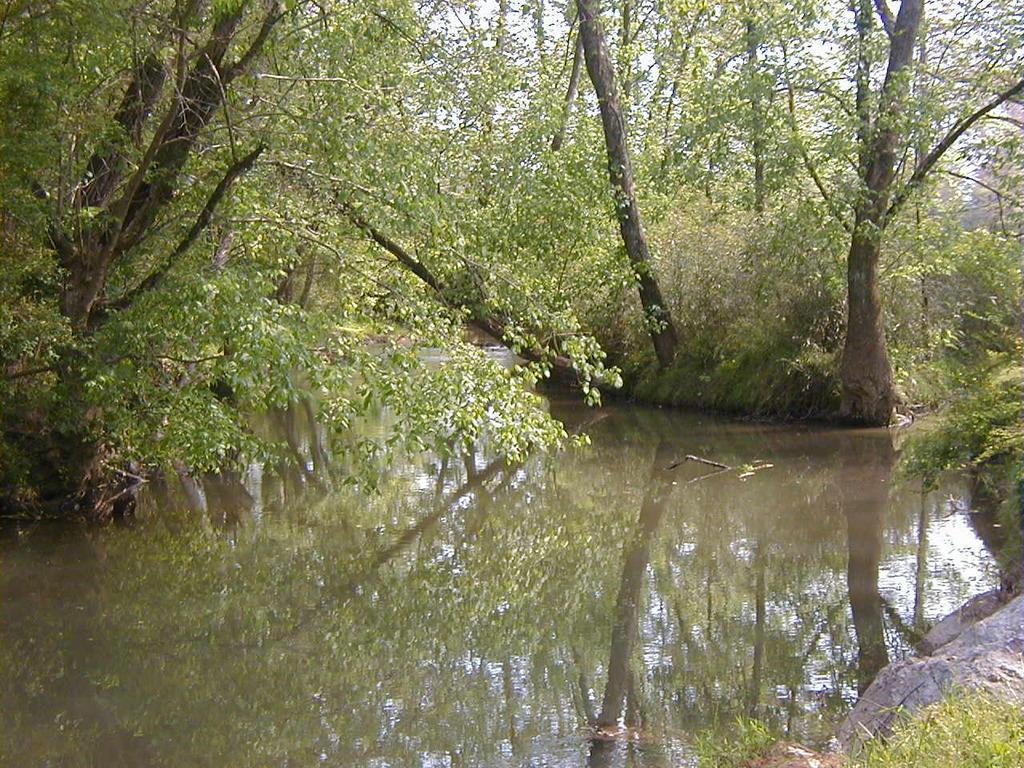How would you summarize this image in a sentence or two? In the picture can see a forest, in the forest we can see a water near the trees, plants, rocks and some parts of sky. 